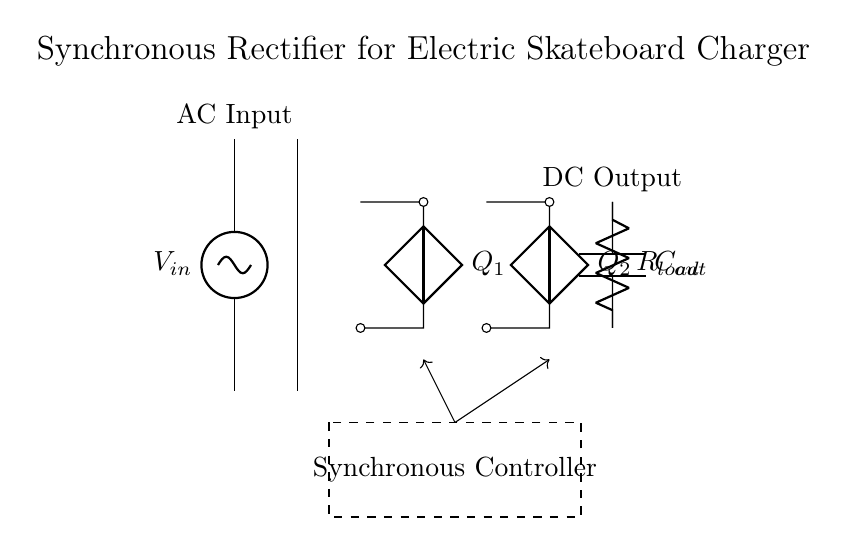What is the input voltage type? The circuit shows an AC source labeled as V_in, indicating the input voltage is alternating current.
Answer: AC What are the two main components after the transformer? The diagram shows two components labeled Q_1 and Q_2, which are both capacitors, indicating they are part of the rectifier bridge.
Answer: Capacitors What is the role of the synchronous controller? The dashed rectangle labeled "Synchronous Controller" in the diagram indicates that its role is to manage the switching of the two capacitors during the rectification process to improve efficiency.
Answer: Improve efficiency What is the function of the output capacitor? The output capacitor labeled as C_out smooths the rectified voltage output by filtering fluctuations, providing a stable DC voltage to the load.
Answer: Filter fluctuations What type of rectifier is depicted in the circuit? The circuit utilizes a synchronous rectifier, as indicated by the synchronous controller that actively switches the components rather than relying on diodes for rectification.
Answer: Synchronous rectifier What is connected to the DC output? The DC output connects to a load resistor labeled as R_load, which consumes the output power from the charger.
Answer: Load resistor 